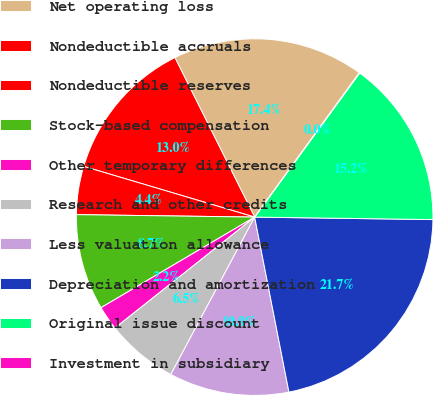Convert chart to OTSL. <chart><loc_0><loc_0><loc_500><loc_500><pie_chart><fcel>Net operating loss<fcel>Nondeductible accruals<fcel>Nondeductible reserves<fcel>Stock-based compensation<fcel>Other temporary differences<fcel>Research and other credits<fcel>Less valuation allowance<fcel>Depreciation and amortization<fcel>Original issue discount<fcel>Investment in subsidiary<nl><fcel>17.36%<fcel>13.03%<fcel>4.37%<fcel>8.7%<fcel>2.2%<fcel>6.53%<fcel>10.87%<fcel>21.7%<fcel>15.2%<fcel>0.04%<nl></chart> 